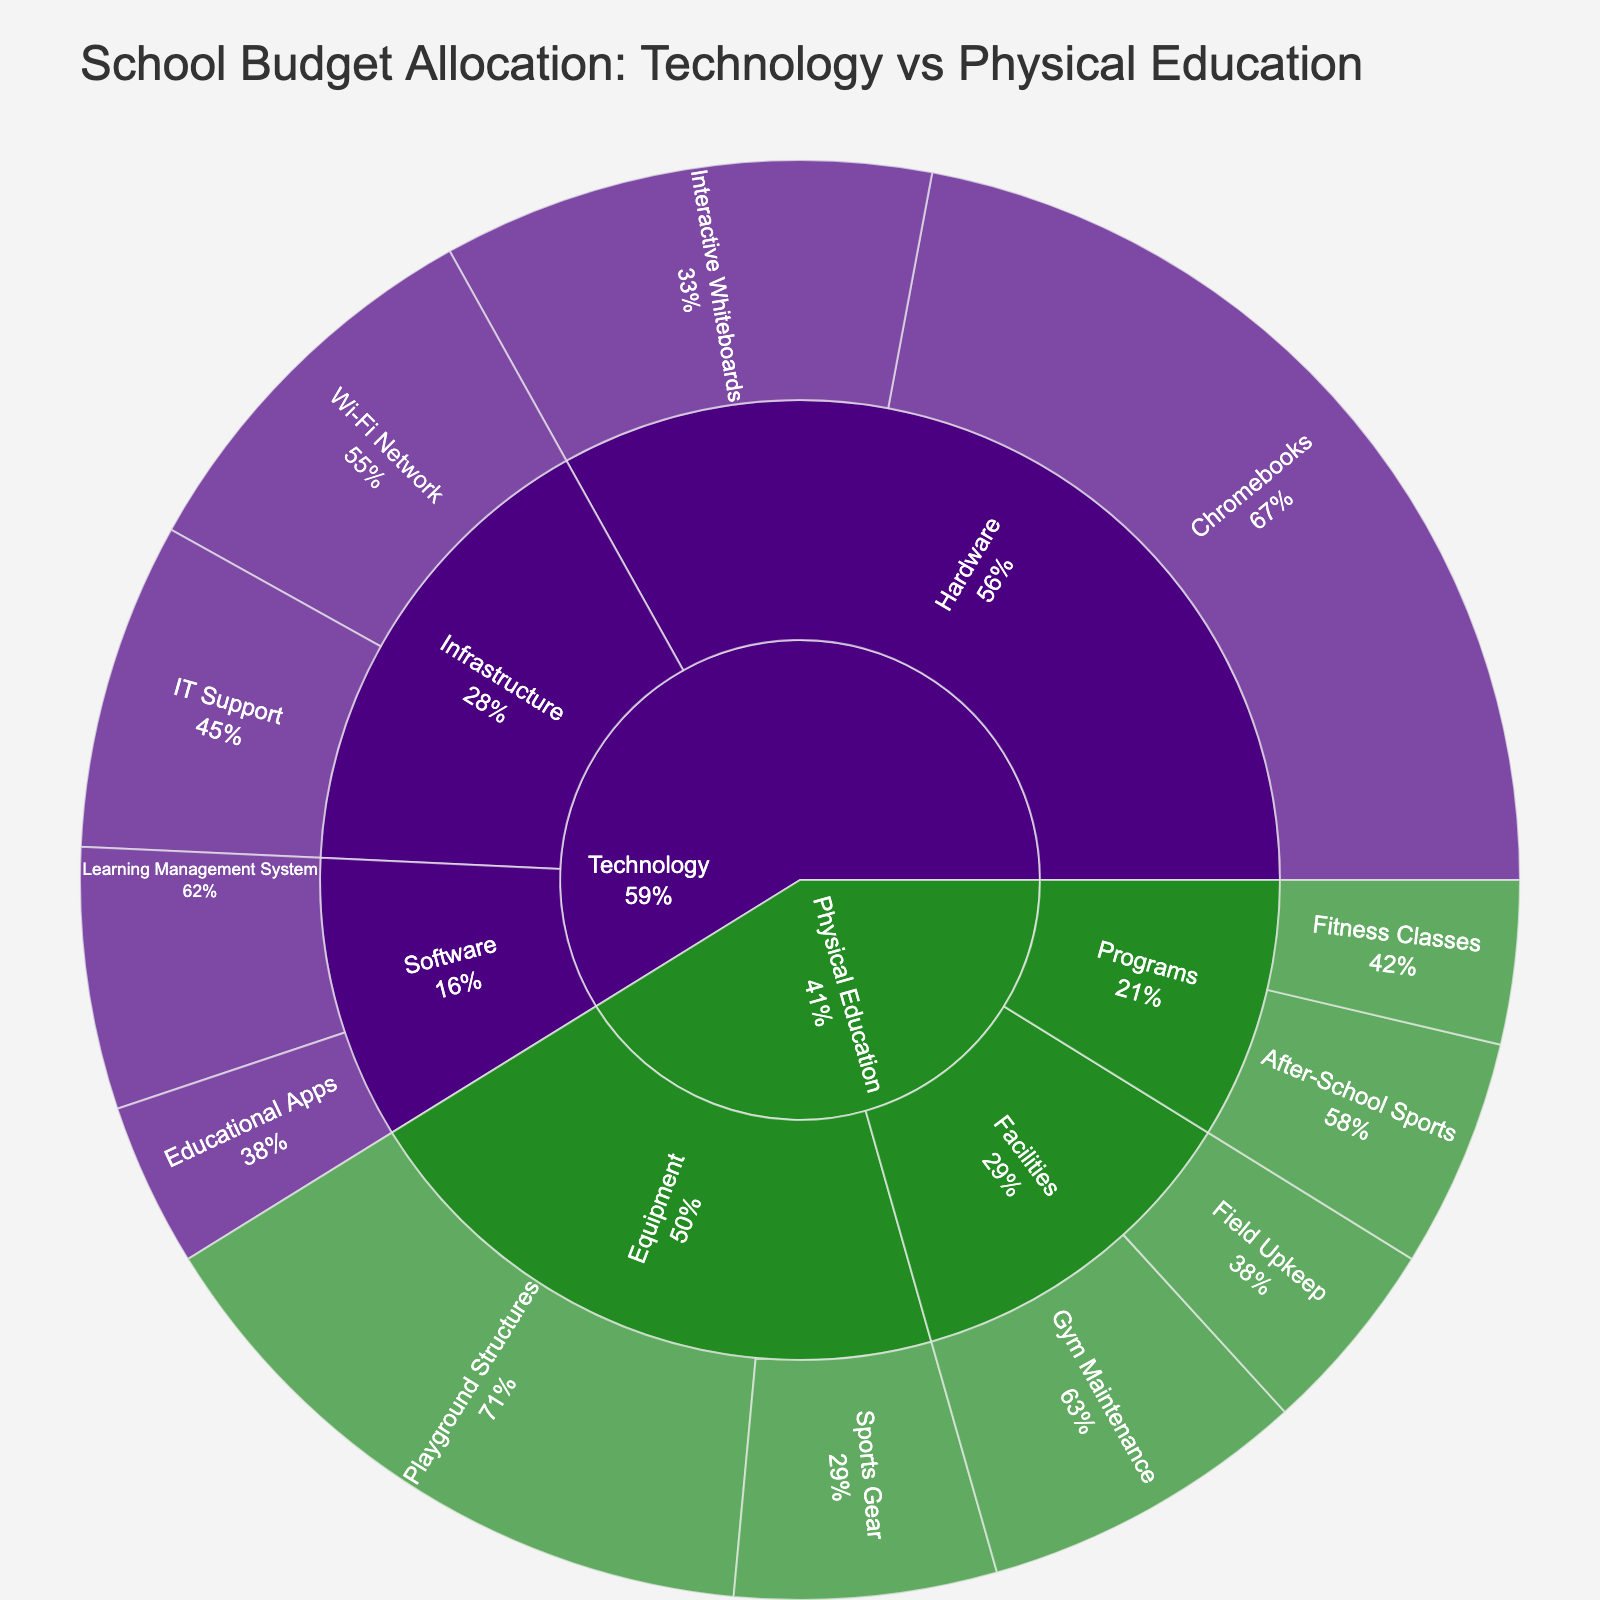what is the title of the sunburst plot? The title is prominently displayed above the figure, which summarizes the main focus of the visualization.
Answer: School Budget Allocation: Technology vs Physical Education What color represents the Technology category in the plot? By looking at the sunburst plot, each category is color-coded for easy differentiation. The Technology category is shown with a characteristic dark purple color.
Answer: Dark purple Which item in the Technology category has the highest budget allocation? Observe the sections under the Technology category. The size of each section in a sunburst plot represents the amount allocated. The Chromebooks section is the largest in the Technology category.
Answer: Chromebooks What percentage of the Physical Education budget is allocated to Equipment? Find the Equipment subcategory within Physical Education and look at the percentage value displayed there to show its portion of the Physical Education budget.
Answer: 48% Which item has the lowest budget allocation in the Physical Education category? Within the Physical Education category, compare the sizes of individual items' sections. The smallest section will indicate the item with the lowest budget.
Answer: Fitness Classes What is the combined budget for Hardware in the Technology category? Sum the values of the Chromebooks and Interactive Whiteboards sections, as both fall under the Hardware subcategory in Technology. 30,000 + 15,000 = 45,000.
Answer: $45,000 How does the budget for Wi-Fi Network compare to Gym Maintenance? Identify the budget values for Wi-Fi Network under Technology and Gym Maintenance under Physical Education, then compare these two values. $12,000 (Wi-Fi Network) vs $10,000 (Gym Maintenance).
Answer: Wi-Fi Network has a higher budget by $2,000 What percentage of the total Technology budget is allocated to Software? Calculate the sum of Educational Apps ($5,000) and Learning Management System ($8,000) to get the total Software budget ($13,000). Then, express this as a percentage of the total Technology budget ($30,000 + $15,000 + $5,000 + $8,000 + $12,000 + $10,000 = $80,000). 13,000 / 80,000 = 16.25%.
Answer: 16.25% What is the total budget allocation for Physical Education? Sum the values of all sections under the Physical Education category. 8000 + 20000 + 7000 + 5000 + 10000 + 6000 = 56,000.
Answer: $56,000 Is the budget allocation for Chromebooks greater than the combined budget for After-School Sports and Fitness Classes? Compare the budget for Chromebooks ($30,000) with the sum of the budgets for After-School Sports ($7,000) and Fitness Classes ($5,000). 7,000 + 5,000 = 12,000, which is less than 30,000.
Answer: Yes 